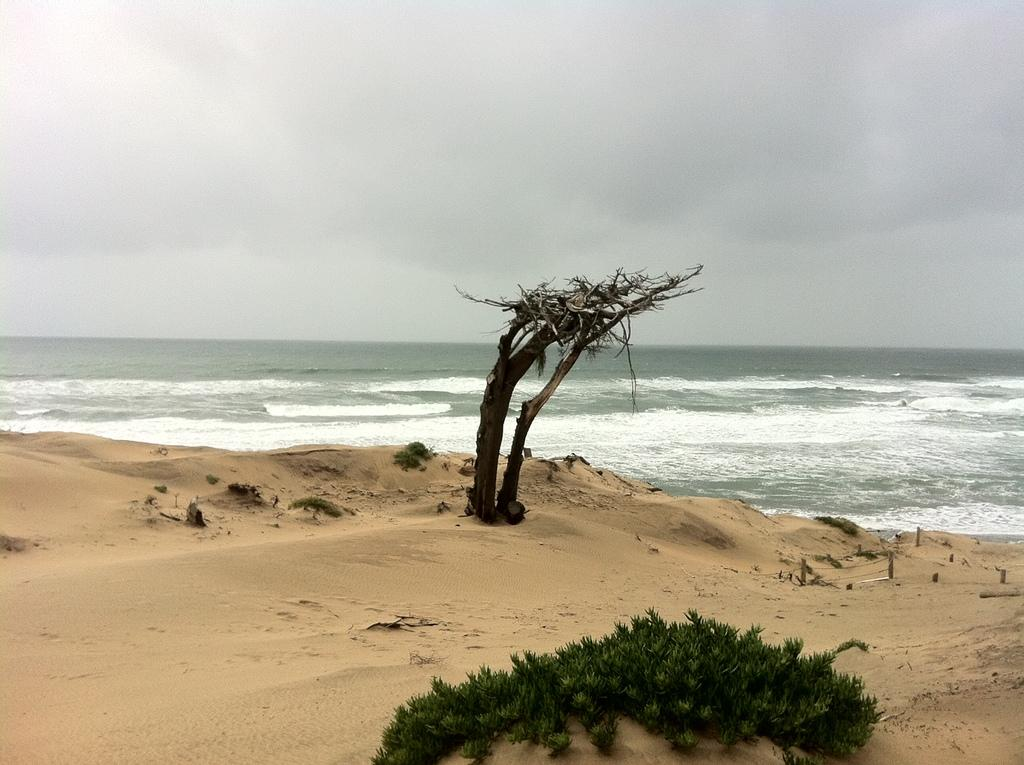What type of vegetation can be seen in the picture? There is a tree and plants visible in the picture. What natural element is present in the picture besides the vegetation? Water is visible in the picture. What is the condition of the sky in the picture? The sky is cloudy in the picture. What opinion does the carpenter have about the trouble in the picture? There is no carpenter or trouble present in the image, so it is not possible to determine any opinions. 